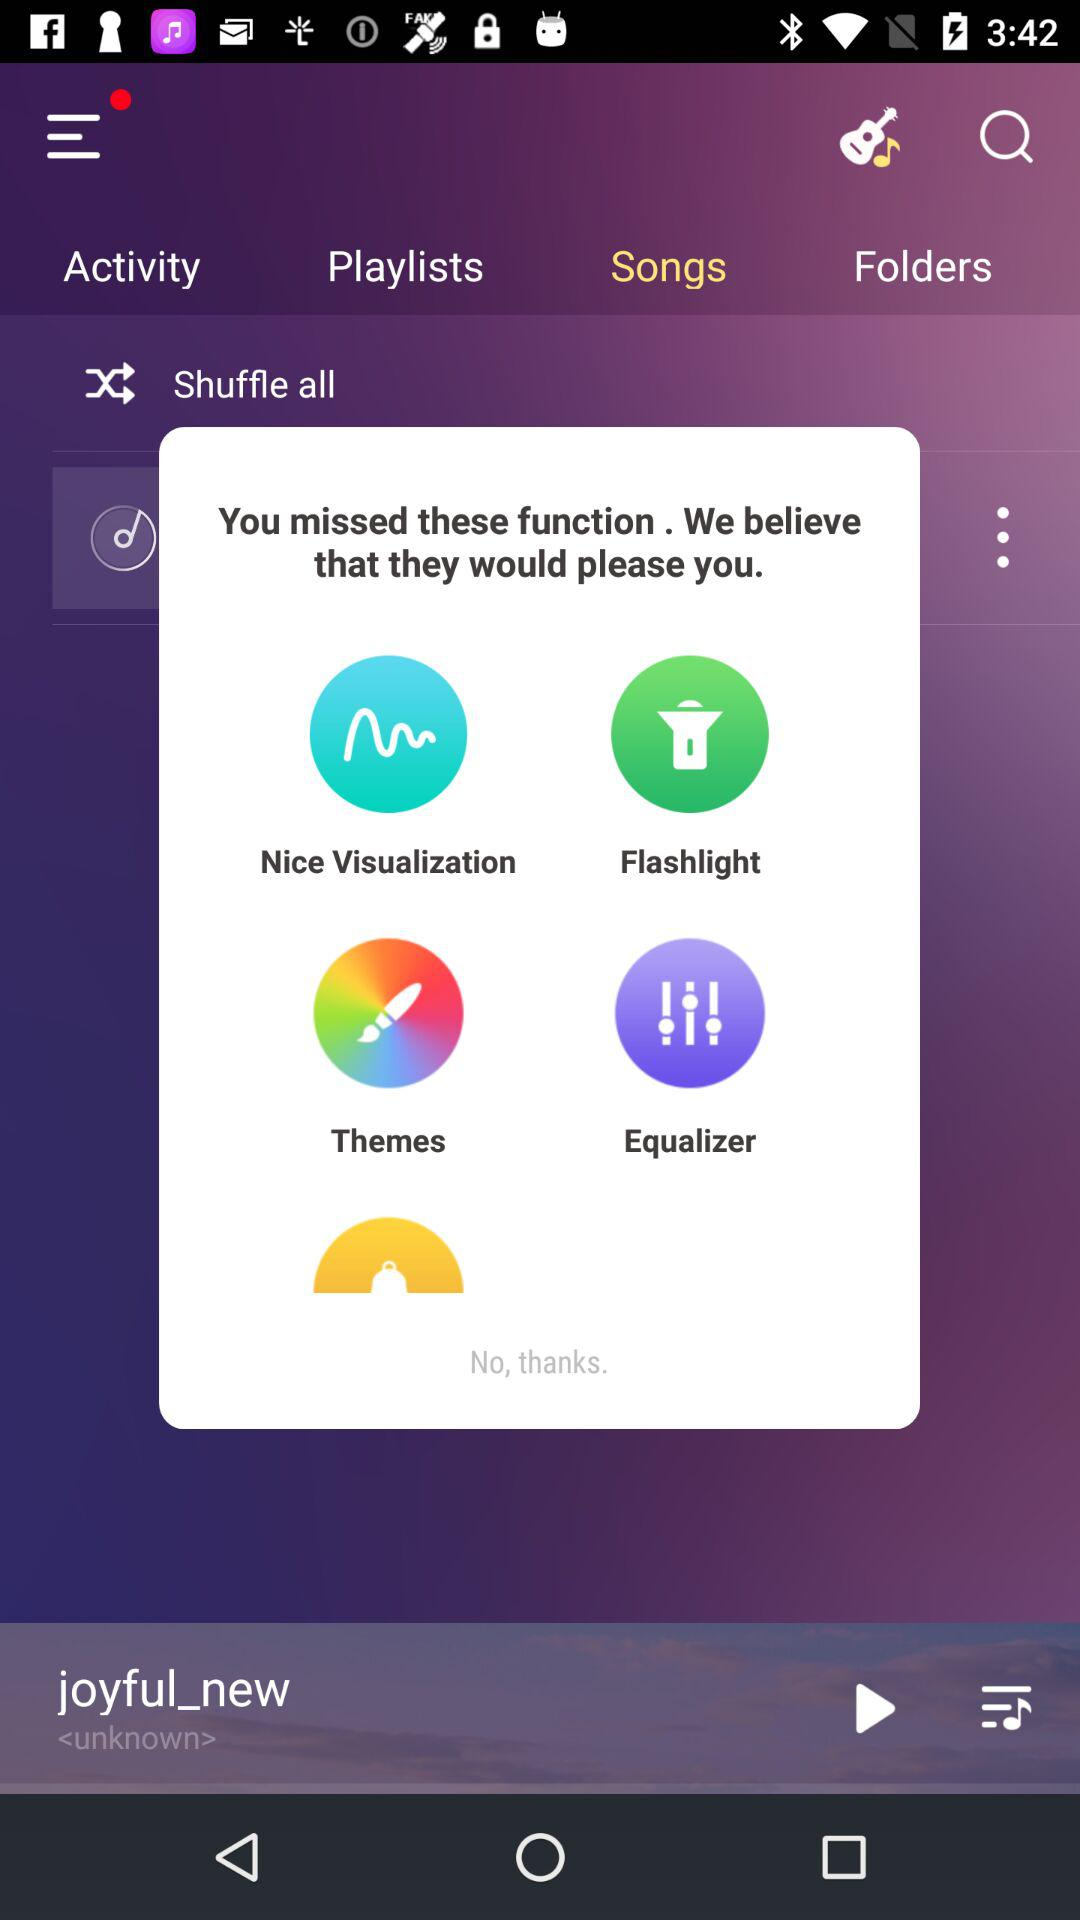Which songs are in the playlist?
When the provided information is insufficient, respond with <no answer>. <no answer> 